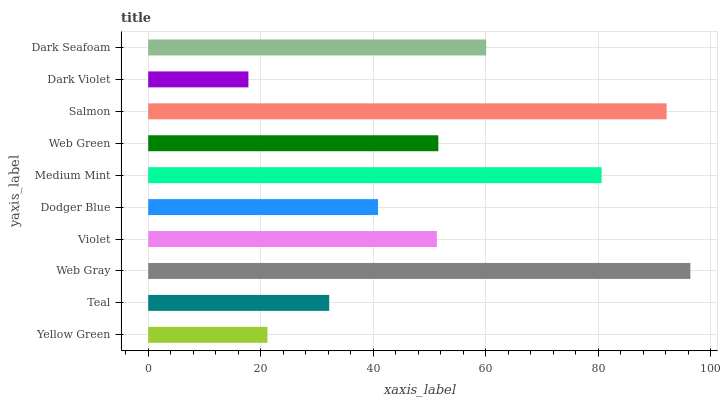Is Dark Violet the minimum?
Answer yes or no. Yes. Is Web Gray the maximum?
Answer yes or no. Yes. Is Teal the minimum?
Answer yes or no. No. Is Teal the maximum?
Answer yes or no. No. Is Teal greater than Yellow Green?
Answer yes or no. Yes. Is Yellow Green less than Teal?
Answer yes or no. Yes. Is Yellow Green greater than Teal?
Answer yes or no. No. Is Teal less than Yellow Green?
Answer yes or no. No. Is Web Green the high median?
Answer yes or no. Yes. Is Violet the low median?
Answer yes or no. Yes. Is Yellow Green the high median?
Answer yes or no. No. Is Dark Seafoam the low median?
Answer yes or no. No. 